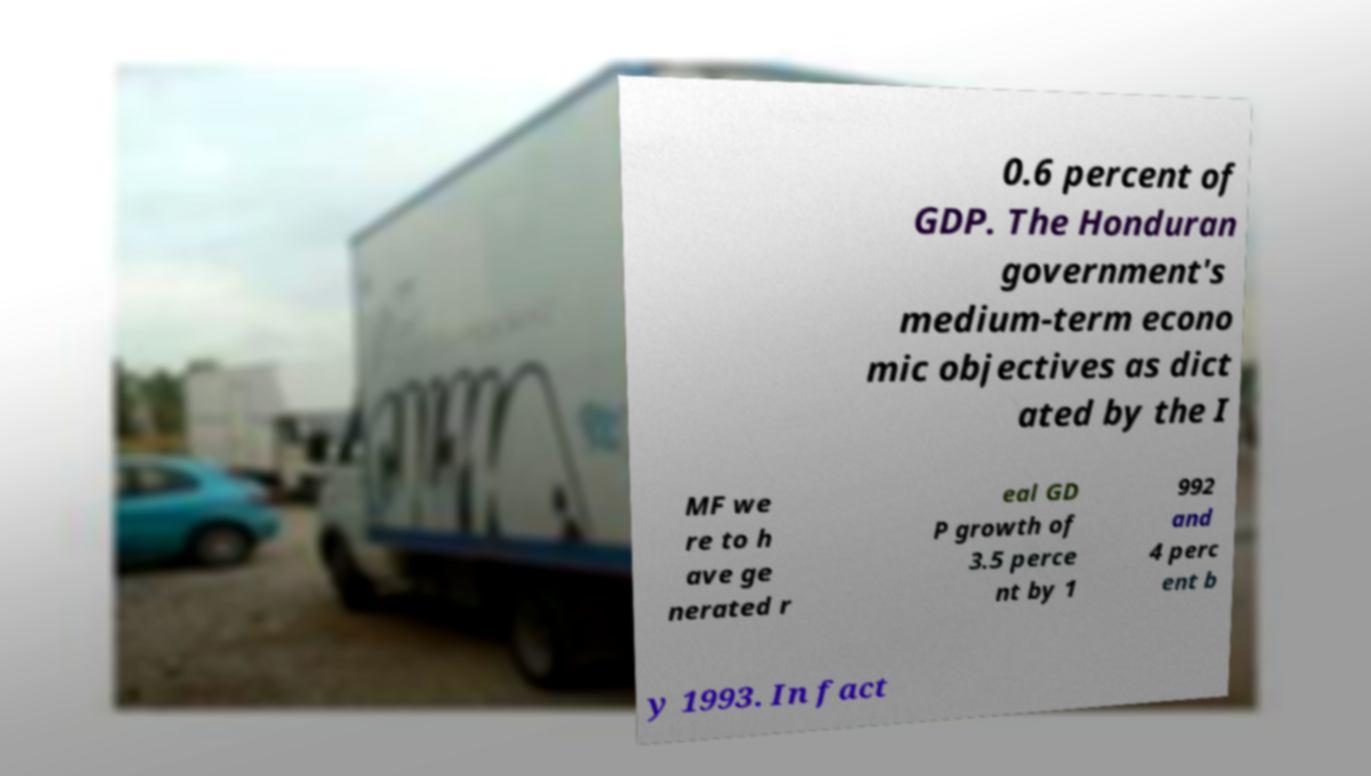Could you extract and type out the text from this image? 0.6 percent of GDP. The Honduran government's medium-term econo mic objectives as dict ated by the I MF we re to h ave ge nerated r eal GD P growth of 3.5 perce nt by 1 992 and 4 perc ent b y 1993. In fact 